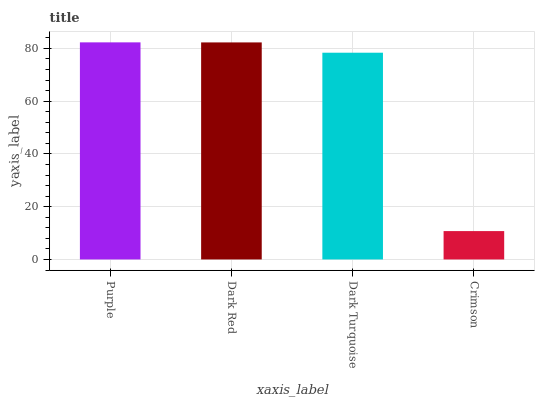Is Crimson the minimum?
Answer yes or no. Yes. Is Purple the maximum?
Answer yes or no. Yes. Is Dark Red the minimum?
Answer yes or no. No. Is Dark Red the maximum?
Answer yes or no. No. Is Purple greater than Dark Red?
Answer yes or no. Yes. Is Dark Red less than Purple?
Answer yes or no. Yes. Is Dark Red greater than Purple?
Answer yes or no. No. Is Purple less than Dark Red?
Answer yes or no. No. Is Dark Red the high median?
Answer yes or no. Yes. Is Dark Turquoise the low median?
Answer yes or no. Yes. Is Crimson the high median?
Answer yes or no. No. Is Purple the low median?
Answer yes or no. No. 